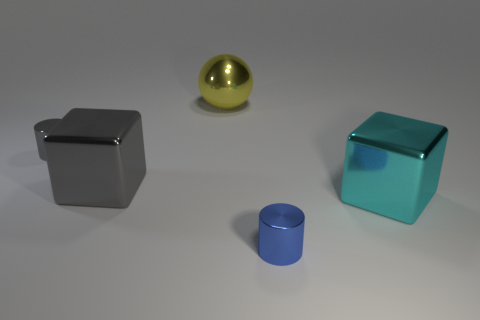What shape is the tiny object that is left of the yellow shiny thing?
Offer a terse response. Cylinder. How many green objects are either small shiny objects or balls?
Give a very brief answer. 0. Are the large gray cube and the small gray cylinder made of the same material?
Your answer should be very brief. Yes. There is a yellow sphere; what number of small cylinders are to the left of it?
Ensure brevity in your answer.  1. What is the large thing that is in front of the yellow metallic thing and to the left of the blue cylinder made of?
Make the answer very short. Metal. What number of spheres are small blue metallic things or small metallic things?
Offer a very short reply. 0. There is another large thing that is the same shape as the large gray thing; what is its material?
Give a very brief answer. Metal. What size is the yellow thing that is the same material as the gray block?
Provide a succinct answer. Large. Do the object behind the tiny gray thing and the tiny metal thing to the left of the large yellow metallic ball have the same shape?
Your answer should be compact. No. What color is the large sphere that is made of the same material as the large cyan thing?
Offer a very short reply. Yellow. 